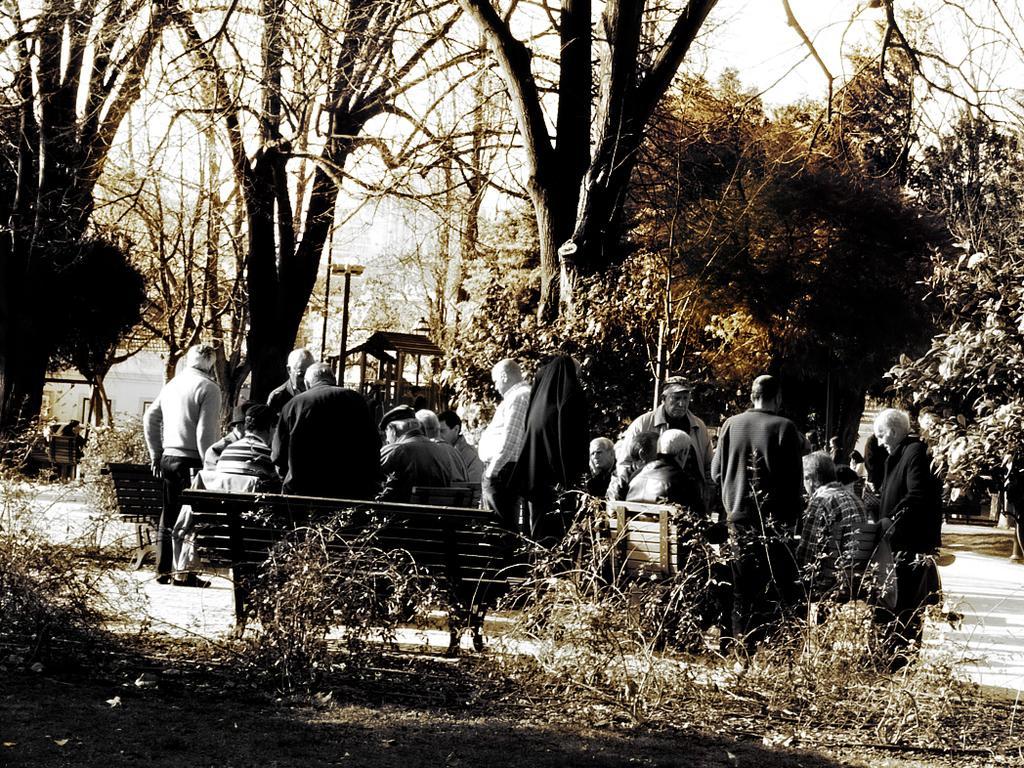Could you give a brief overview of what you see in this image? In this image in the center there are a group of people who are sitting and some of them are standing. At the bottom there is grass and some sand, and in the background there are some trees and poles. 